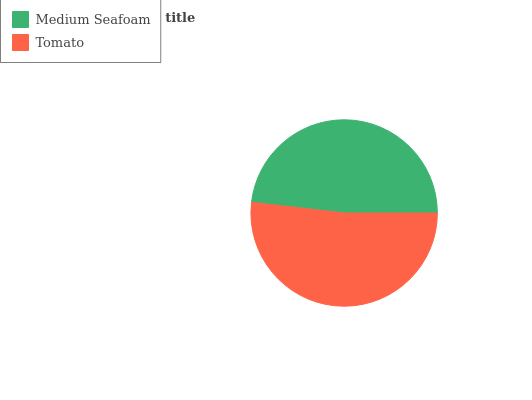Is Medium Seafoam the minimum?
Answer yes or no. Yes. Is Tomato the maximum?
Answer yes or no. Yes. Is Tomato the minimum?
Answer yes or no. No. Is Tomato greater than Medium Seafoam?
Answer yes or no. Yes. Is Medium Seafoam less than Tomato?
Answer yes or no. Yes. Is Medium Seafoam greater than Tomato?
Answer yes or no. No. Is Tomato less than Medium Seafoam?
Answer yes or no. No. Is Tomato the high median?
Answer yes or no. Yes. Is Medium Seafoam the low median?
Answer yes or no. Yes. Is Medium Seafoam the high median?
Answer yes or no. No. Is Tomato the low median?
Answer yes or no. No. 